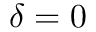<formula> <loc_0><loc_0><loc_500><loc_500>\delta = 0</formula> 